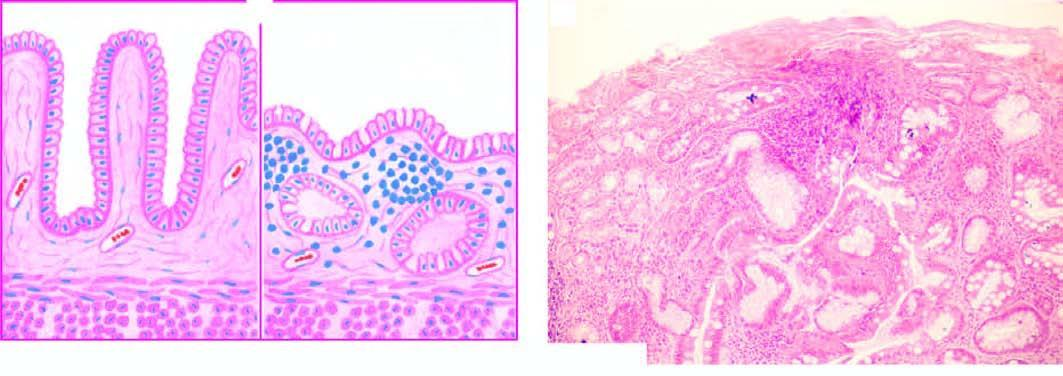s there marked gastric atrophy with disappearance of gastric glands and appearance of goblet cells intestinal metaplasia?
Answer the question using a single word or phrase. Yes 